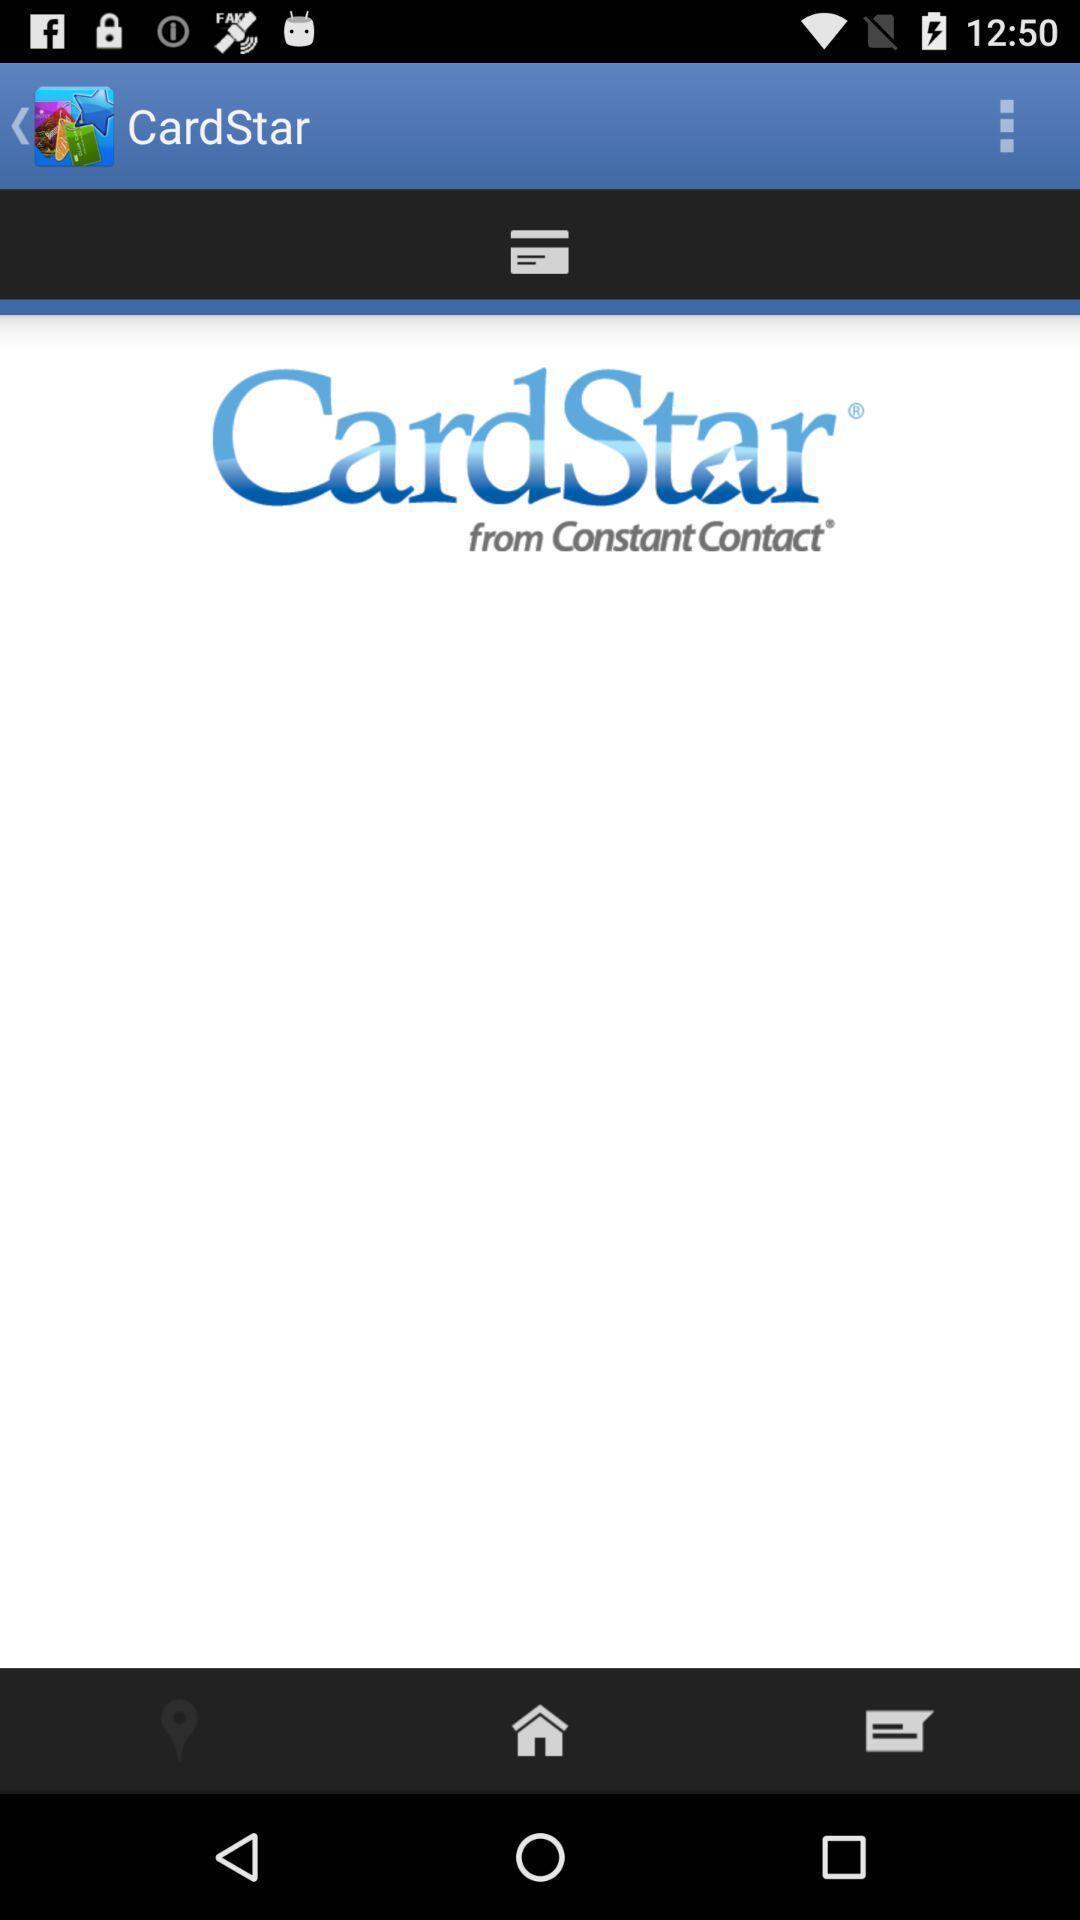Tell me about the visual elements in this screen capture. Welcome page with buttons. 